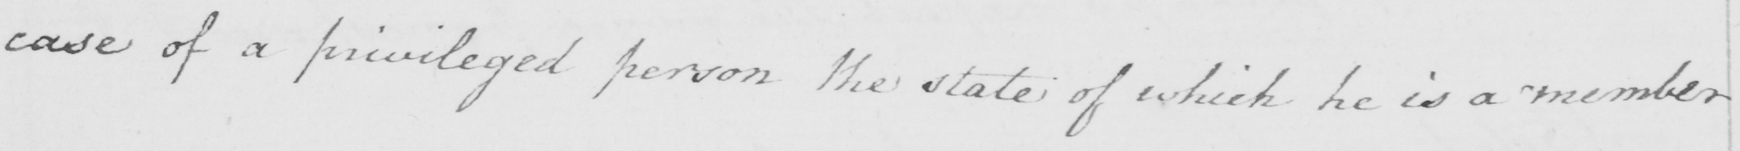What does this handwritten line say? case of a privileged person the state of which he is a member 